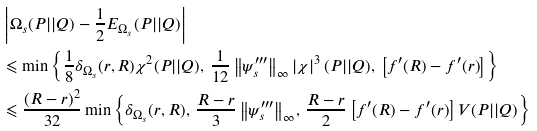Convert formula to latex. <formula><loc_0><loc_0><loc_500><loc_500>& \left | { \Omega _ { s } ( P | | Q ) - \frac { 1 } { 2 } E _ { \Omega _ { s } } ( P | | Q ) } \right | \\ & \leqslant \min \left \{ { \frac { 1 } { 8 } \delta _ { \Omega _ { s } } ( r , R ) \chi ^ { 2 } ( P | | Q ) , \, \frac { 1 } { 1 2 } \left \| { \psi _ { s } ^ { \prime \prime \prime } } \right \| _ { \infty } \left | \chi \right | ^ { 3 } ( P | | Q ) } , \, \left [ { { f } ^ { \prime } ( R ) - { f } ^ { \prime } ( r ) } \right ] \right \} \\ & \leqslant \frac { ( R - r ) ^ { 2 } } { 3 2 } \min \left \{ { \delta _ { \Omega _ { s } } ( r , R ) , \, \frac { R - r } { 3 } \left \| { \psi _ { s } ^ { \prime \prime \prime } } \right \| _ { \infty } } , \, \frac { R - r } { 2 } \left [ { { f } ^ { \prime } ( R ) - { f } ^ { \prime } ( r ) } \right ] V ( P | | Q ) \right \}</formula> 